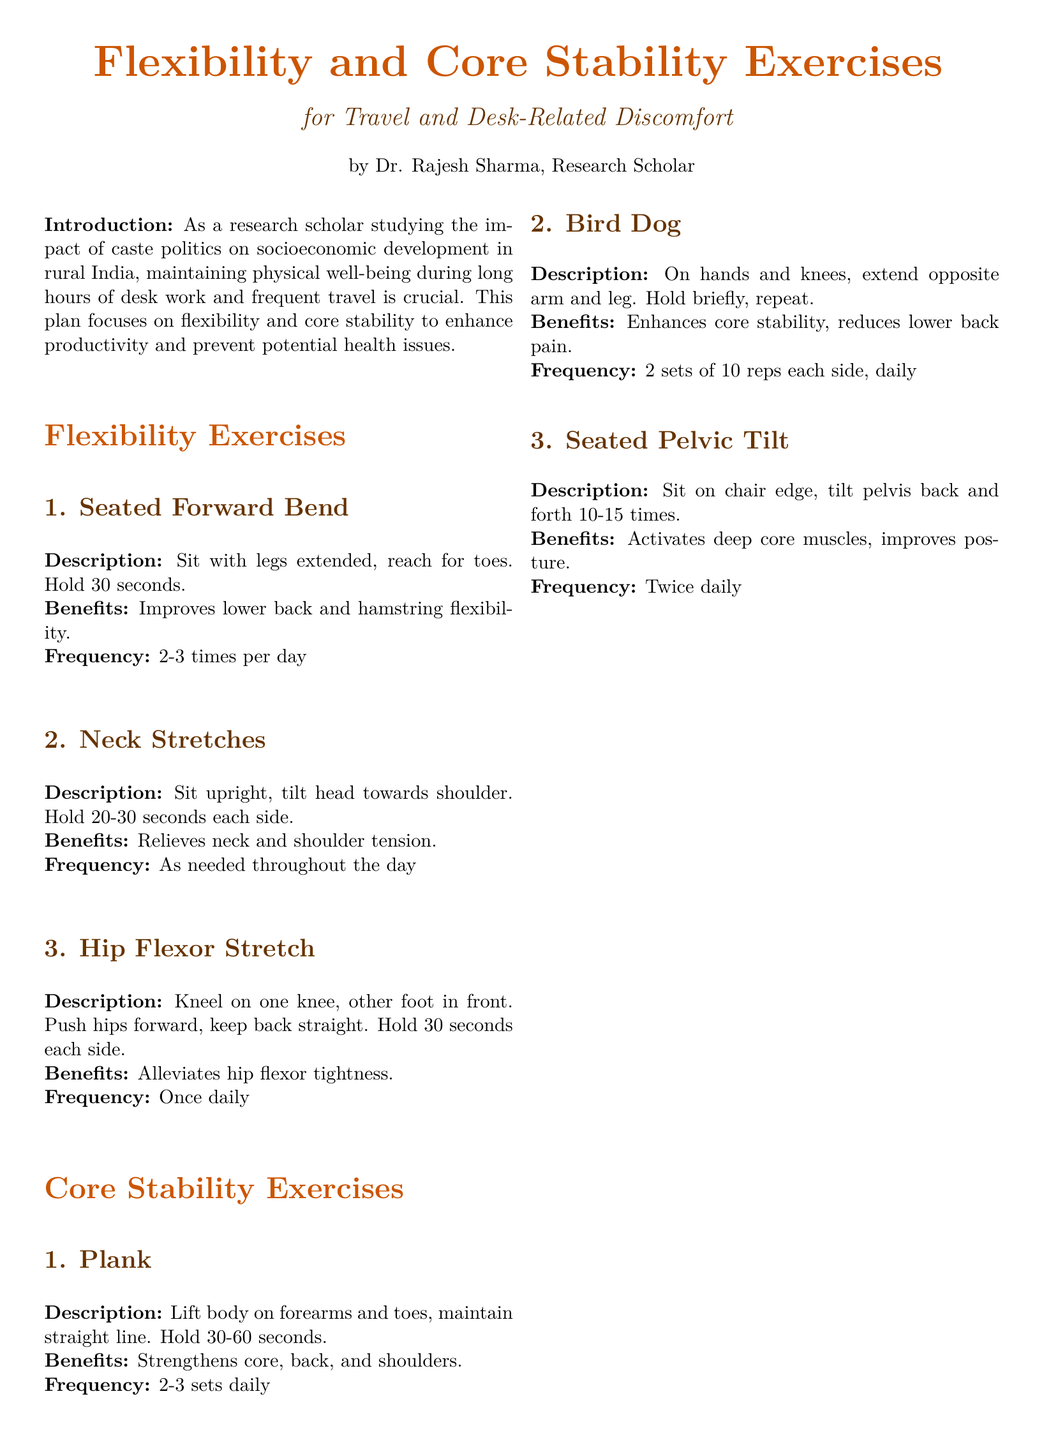What is the title of the document? The title is prominently displayed at the top of the document.
Answer: Flexibility and Core Stability Exercises Who is the author of the workout plan? The author's name is mentioned at the end of the title section.
Answer: Dr. Rajesh Sharma How long should the Seated Forward Bend be held? The duration for holding the exercise is specified in the description.
Answer: 30 seconds What is the frequency of performing Neck Stretches? The frequency is indicated in the description of the exercise.
Answer: As needed throughout the day What is the benefit of the Plank exercise? The benefits of the Plank are listed in its description.
Answer: Strengthens core, back, and shoulders How many repetitions of the Bird Dog should be done on each side? The number of repetitions is specified in the exercise description.
Answer: 10 reps each side Which exercise helps alleviate hip flexor tightness? The specific exercise that addresses this issue is mentioned.
Answer: Hip Flexor Stretch What is the primary purpose of the workout plan? The purpose is summarized in the introduction at the beginning of the document.
Answer: Enhance productivity and prevent health issues How many sets of the Plank exercise should be performed daily? The number of sets is stated in the exercise description.
Answer: 2-3 sets daily 